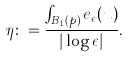<formula> <loc_0><loc_0><loc_500><loc_500>\eta \colon = \frac { \int _ { B _ { 1 } ( p ) } e _ { \epsilon } ( u ) } { | \log \epsilon | } .</formula> 